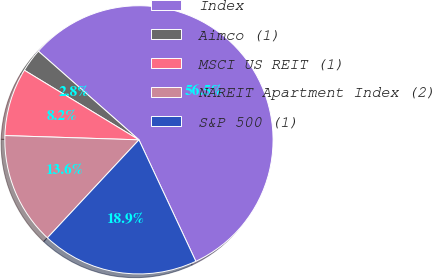Convert chart. <chart><loc_0><loc_0><loc_500><loc_500><pie_chart><fcel>Index<fcel>Aimco (1)<fcel>MSCI US REIT (1)<fcel>NAREIT Apartment Index (2)<fcel>S&P 500 (1)<nl><fcel>56.53%<fcel>2.81%<fcel>8.18%<fcel>13.55%<fcel>18.93%<nl></chart> 